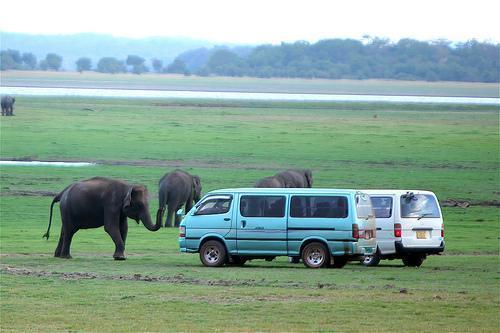How many vehicles do you see?
Give a very brief answer. 2. 